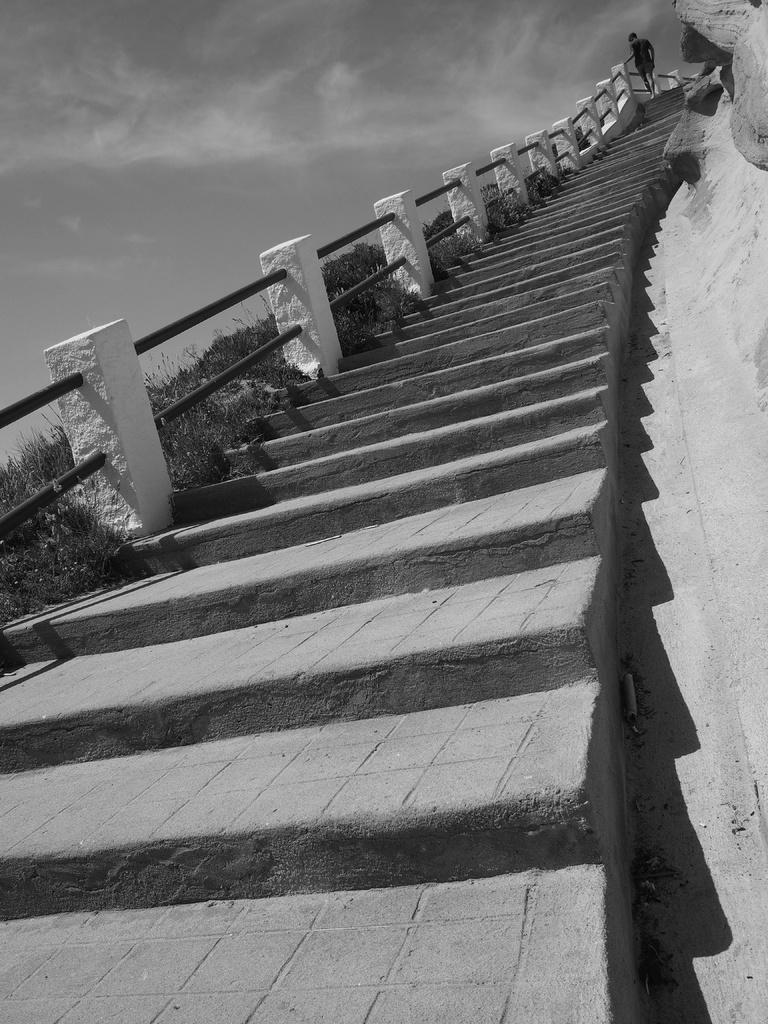What is the main subject of the image? The main subject of the image is a person walking. Where is the person walking in the image? The person is walking on steps. What can be seen in the background of the image? Plants and the sky are visible in the image. What type of clover is growing on the person's head in the image? There is no clover visible on the person's head in the image. Who is the owner of the person walking in the image? The concept of an "owner" does not apply to people, so this question cannot be answered. 